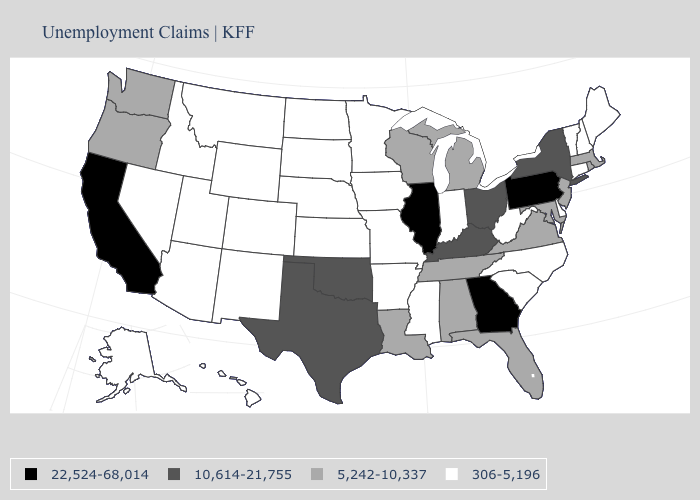What is the value of New York?
Write a very short answer. 10,614-21,755. What is the highest value in states that border California?
Give a very brief answer. 5,242-10,337. Name the states that have a value in the range 10,614-21,755?
Write a very short answer. Kentucky, New York, Ohio, Oklahoma, Texas. What is the value of Massachusetts?
Write a very short answer. 5,242-10,337. Among the states that border California , which have the highest value?
Answer briefly. Oregon. Name the states that have a value in the range 306-5,196?
Concise answer only. Alaska, Arizona, Arkansas, Colorado, Connecticut, Delaware, Hawaii, Idaho, Indiana, Iowa, Kansas, Maine, Minnesota, Mississippi, Missouri, Montana, Nebraska, Nevada, New Hampshire, New Mexico, North Carolina, North Dakota, South Carolina, South Dakota, Utah, Vermont, West Virginia, Wyoming. Name the states that have a value in the range 5,242-10,337?
Keep it brief. Alabama, Florida, Louisiana, Maryland, Massachusetts, Michigan, New Jersey, Oregon, Rhode Island, Tennessee, Virginia, Washington, Wisconsin. Name the states that have a value in the range 5,242-10,337?
Be succinct. Alabama, Florida, Louisiana, Maryland, Massachusetts, Michigan, New Jersey, Oregon, Rhode Island, Tennessee, Virginia, Washington, Wisconsin. Does Georgia have the highest value in the USA?
Give a very brief answer. Yes. Name the states that have a value in the range 22,524-68,014?
Answer briefly. California, Georgia, Illinois, Pennsylvania. What is the value of Indiana?
Concise answer only. 306-5,196. Among the states that border Louisiana , does Arkansas have the highest value?
Answer briefly. No. Among the states that border New Mexico , which have the lowest value?
Write a very short answer. Arizona, Colorado, Utah. What is the lowest value in the USA?
Give a very brief answer. 306-5,196. Name the states that have a value in the range 306-5,196?
Keep it brief. Alaska, Arizona, Arkansas, Colorado, Connecticut, Delaware, Hawaii, Idaho, Indiana, Iowa, Kansas, Maine, Minnesota, Mississippi, Missouri, Montana, Nebraska, Nevada, New Hampshire, New Mexico, North Carolina, North Dakota, South Carolina, South Dakota, Utah, Vermont, West Virginia, Wyoming. 